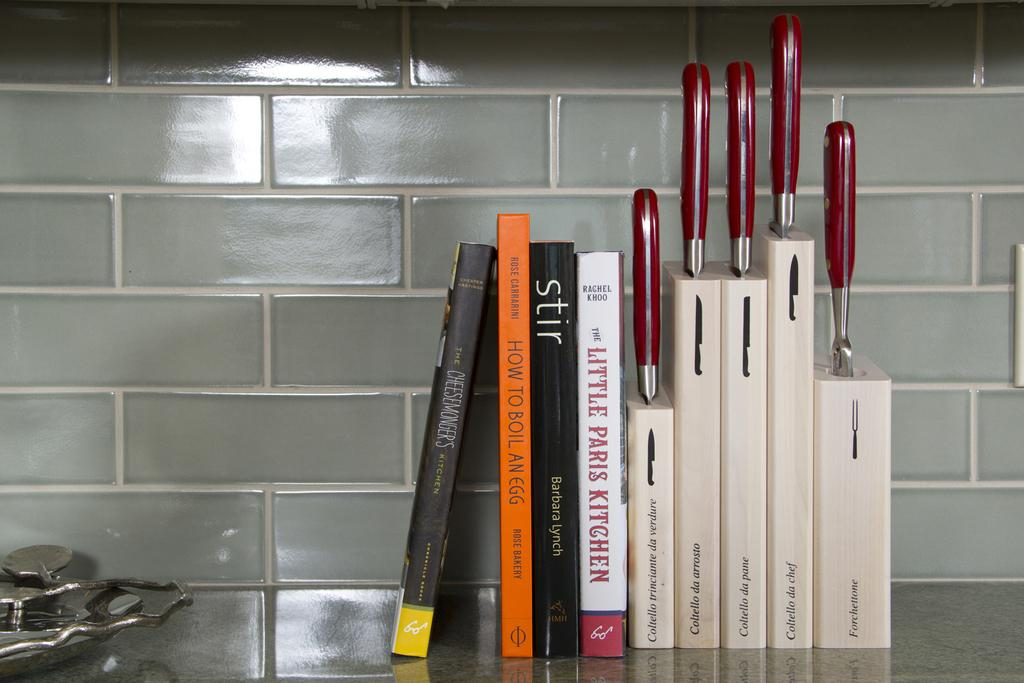<image>
Share a concise interpretation of the image provided. A collection of knives sits next to a stack of cook books. 